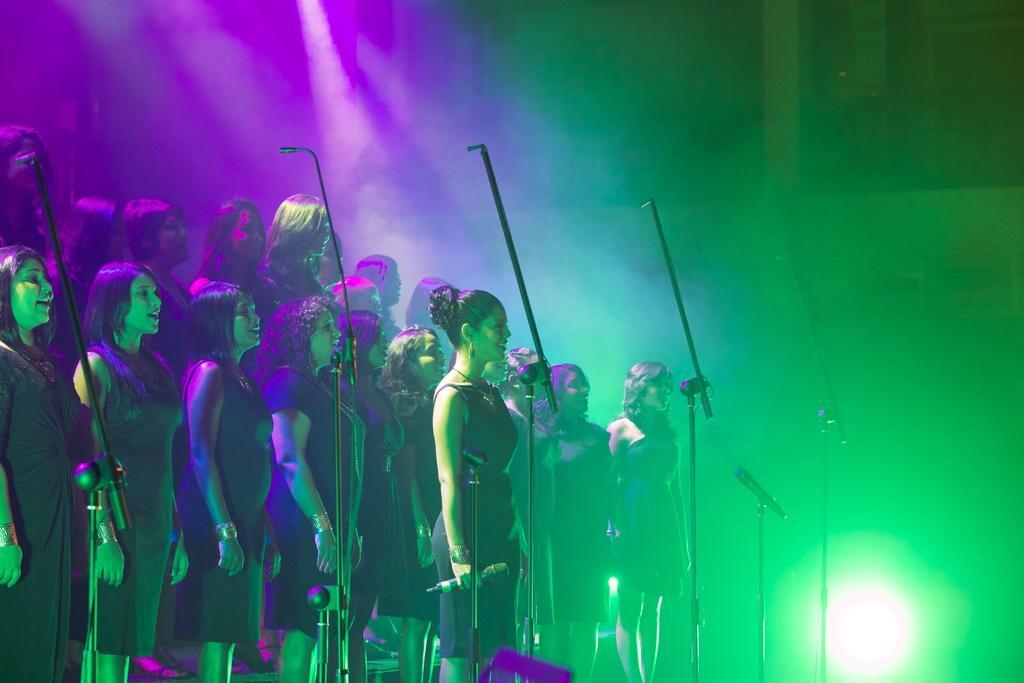Please provide a concise description of this image. In this picture we can see a group of people standing and singing a song and a woman is holding a microphone. In front of the people there are stands and a microphone. Behind the people there is smoke and some objects. 